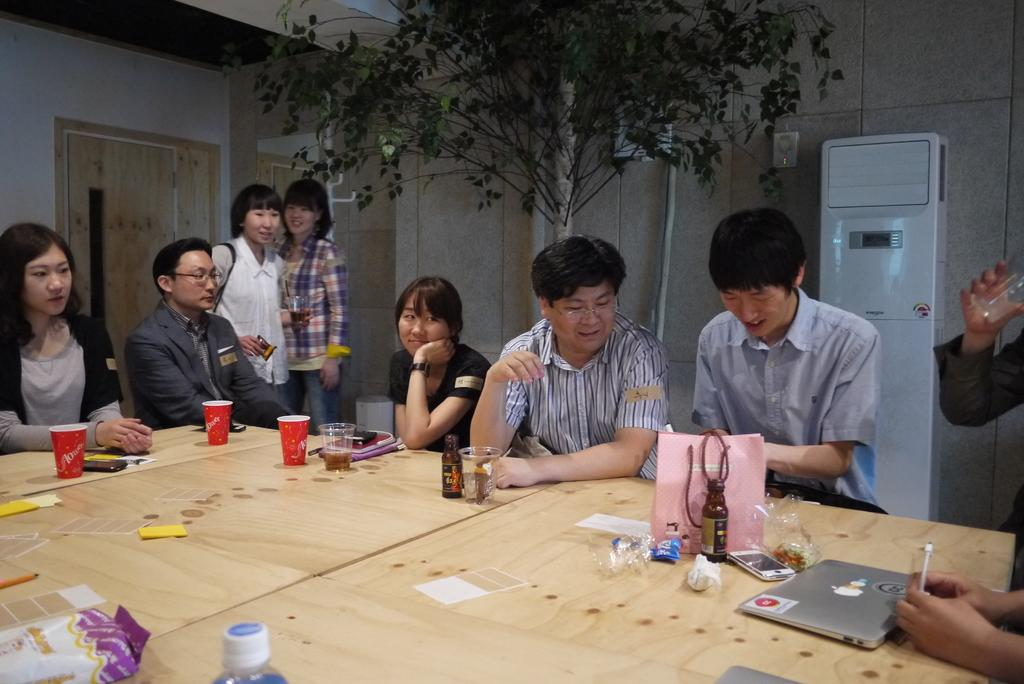What are the people in the image doing? There are persons sitting and standing in the image. What objects can be seen on the table? There are glasses, a bottle, a cover, a laptop, and papers on the table. How many doors are visible in the background? There are three doors visible in the background. What is the background of the image? There is a wall visible in the background. What type of shirt is the system wearing in the image? There is no system or shirt present in the image. What is the tendency of the persons in the image? The provided facts do not mention any specific tendency of the persons in the image. 